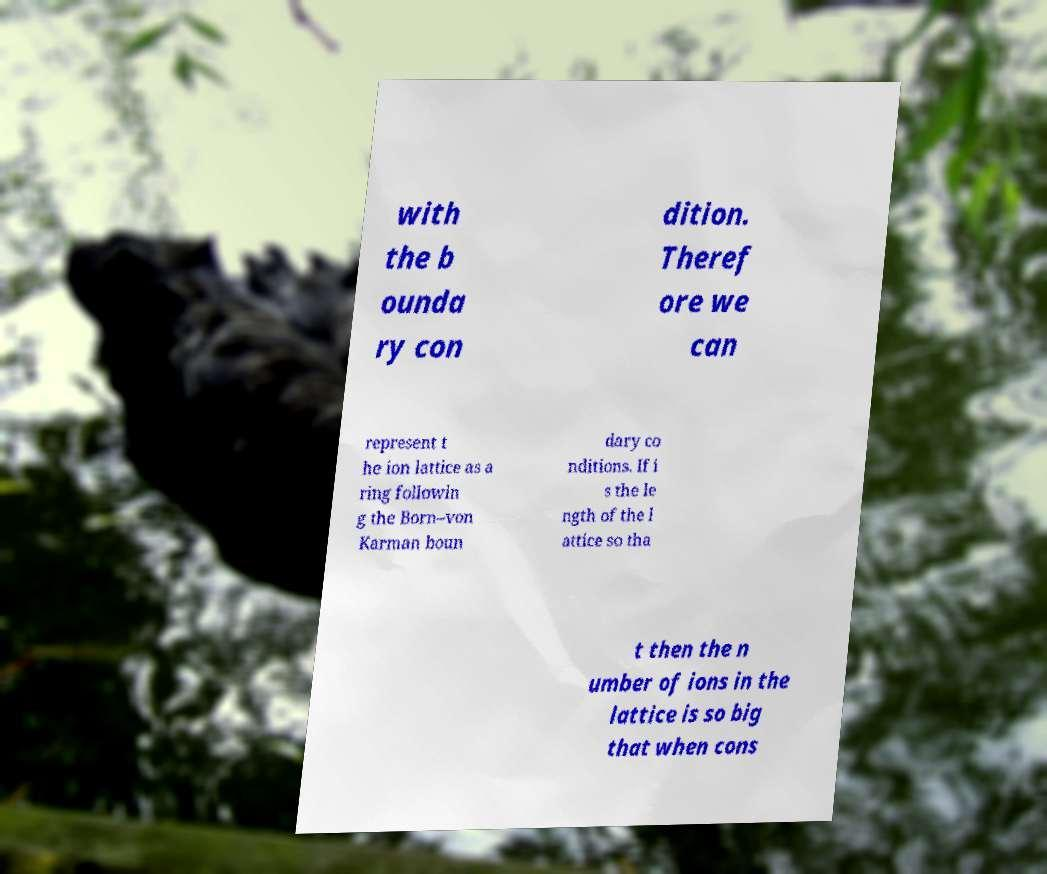There's text embedded in this image that I need extracted. Can you transcribe it verbatim? with the b ounda ry con dition. Theref ore we can represent t he ion lattice as a ring followin g the Born–von Karman boun dary co nditions. If i s the le ngth of the l attice so tha t then the n umber of ions in the lattice is so big that when cons 